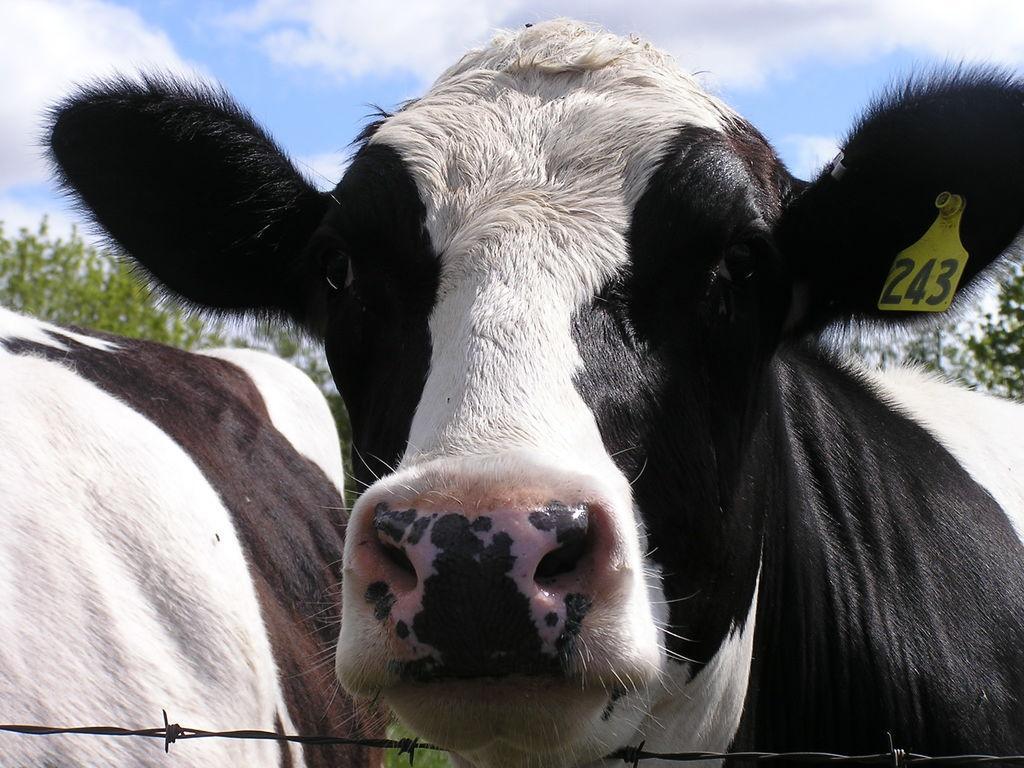Could you give a brief overview of what you see in this image? On the right side, there is an animal in black and white color combination. In front of this animal, there is a fence. On the left side, there is another animal. In the background, there are trees and there are clouds in the blue sky. 